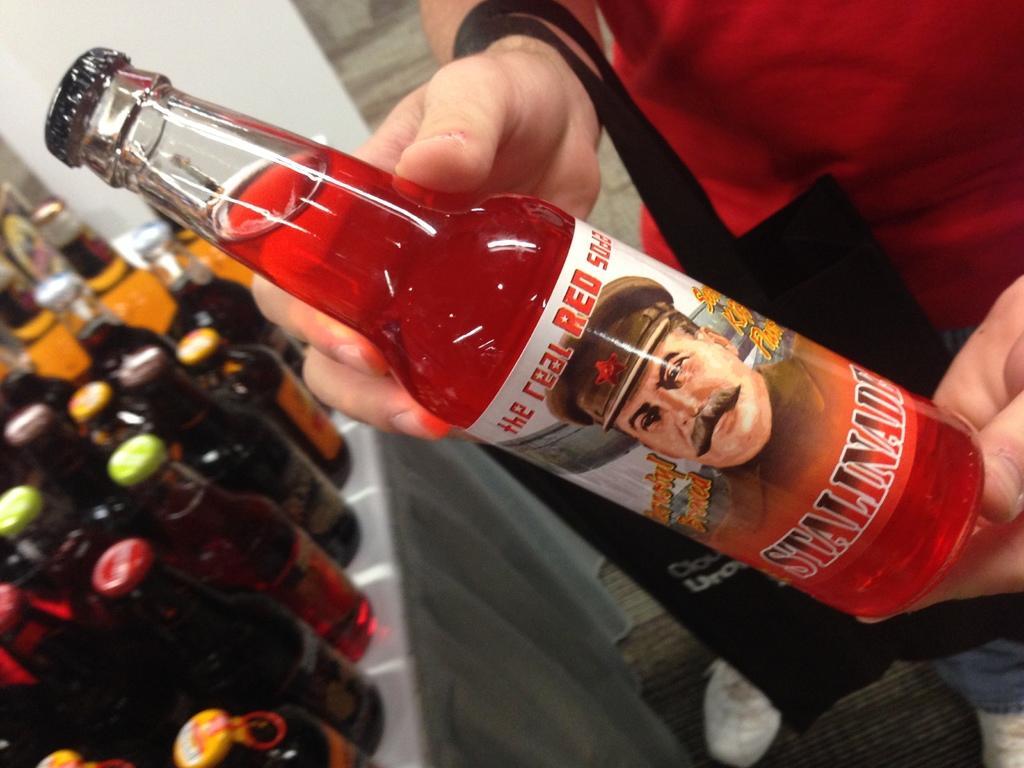Describe this image in one or two sentences. The person wearing red dress is holding a bottle which has red drink in it and there are some of the bottles placed on a table in the left corner. 